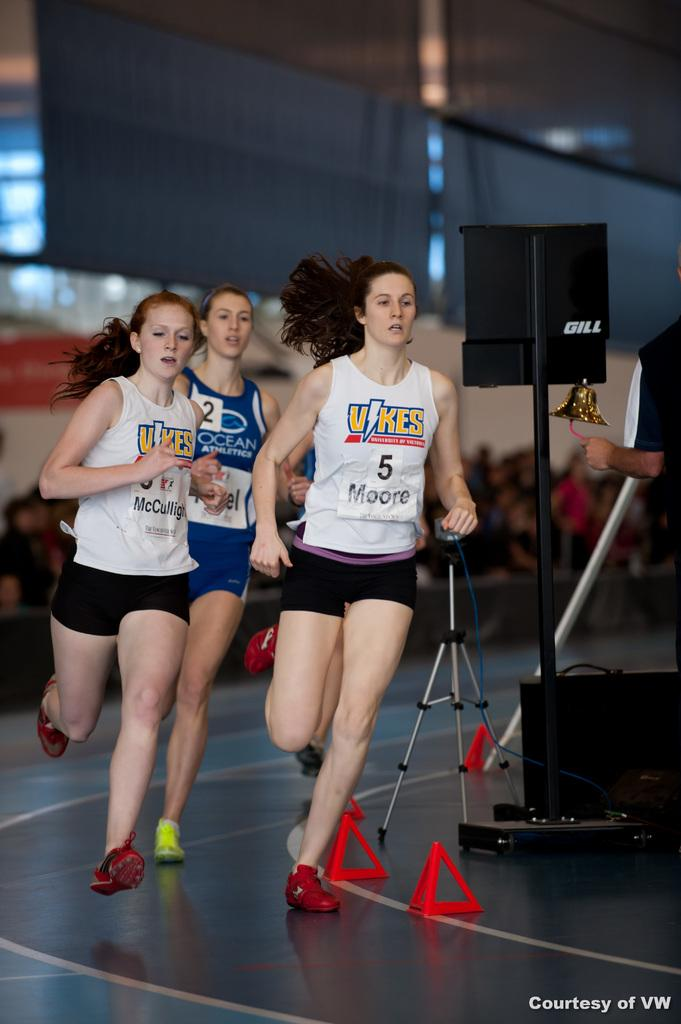<image>
Share a concise interpretation of the image provided. Three women running down a track with the vikes logo on their chests. 